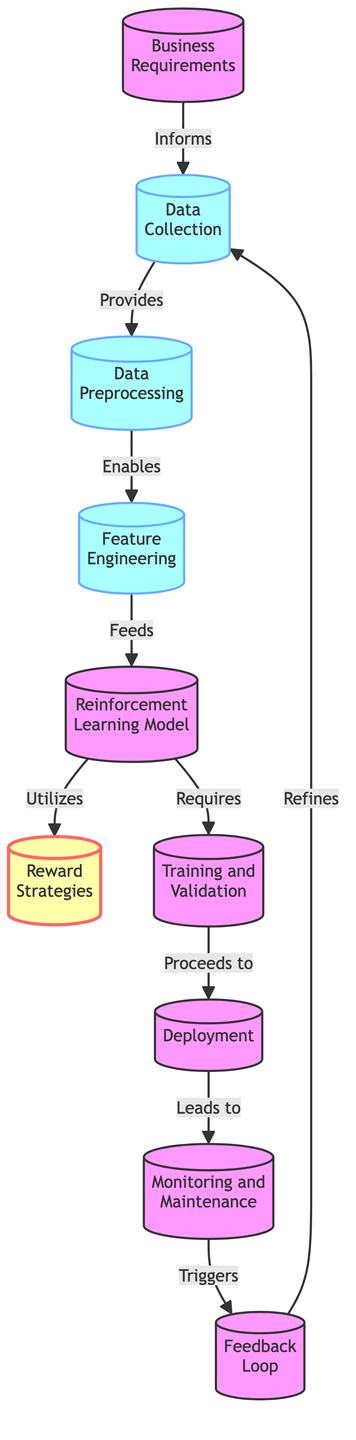What node is responsible for defining the business requirements? The first node is labeled "Business Requirements," indicating that it is responsible for defining the business needs and objectives in this supply chain optimization diagram.
Answer: Business Requirements How many nodes are labeled as data-related processes? The nodes labeled as data-related processes include "Data Collection," "Data Preprocessing," and "Feature Engineering." There are three such nodes in total.
Answer: 3 What is the relationship between the "Reinforcement Learning Model" and "Reward Strategies"? The "Reinforcement Learning Model" utilizes the "Reward Strategies," which means that the model applies the defined strategies to optimize outcomes based on rewards.
Answer: Utilizes Which node directly connects to "Deployment"? The node that directly connects to "Deployment" is "Training and Validation," indicating that the training and validation process proceeds to deployment in the flow.
Answer: Training and Validation What feedback mechanism is shown in the diagram? The diagram illustrates a feedback loop where the "Feedback Loop" triggers improvements or refinements back to the "Data Collection" node. This reinforces that feedback integrates into the data collection process.
Answer: Feedback Loop What step comes before "Monitoring and Maintenance"? "Deployment" is the step that comes before "Monitoring and Maintenance," showing that monitoring occurs after the system has been deployed.
Answer: Deployment What is the purpose of the "Feature Engineering" node? The "Feature Engineering" node enables the extraction and creation of relevant features from the preprocessed data to improve the input for the reinforcement learning model.
Answer: Enables Which node has the most direct impact on "Data Collection"? The "Business Requirements" node has the most direct impact on "Data Collection," as it informs the data that needs to be collected based on the business needs.
Answer: Business Requirements How does the "Monitoring and Maintenance" node relate to the "Feedback Loop"? "Monitoring and Maintenance" leads to the "Feedback Loop," meaning that monitoring practices inform the feedback processes that refine earlier steps in the diagram.
Answer: Leads to 